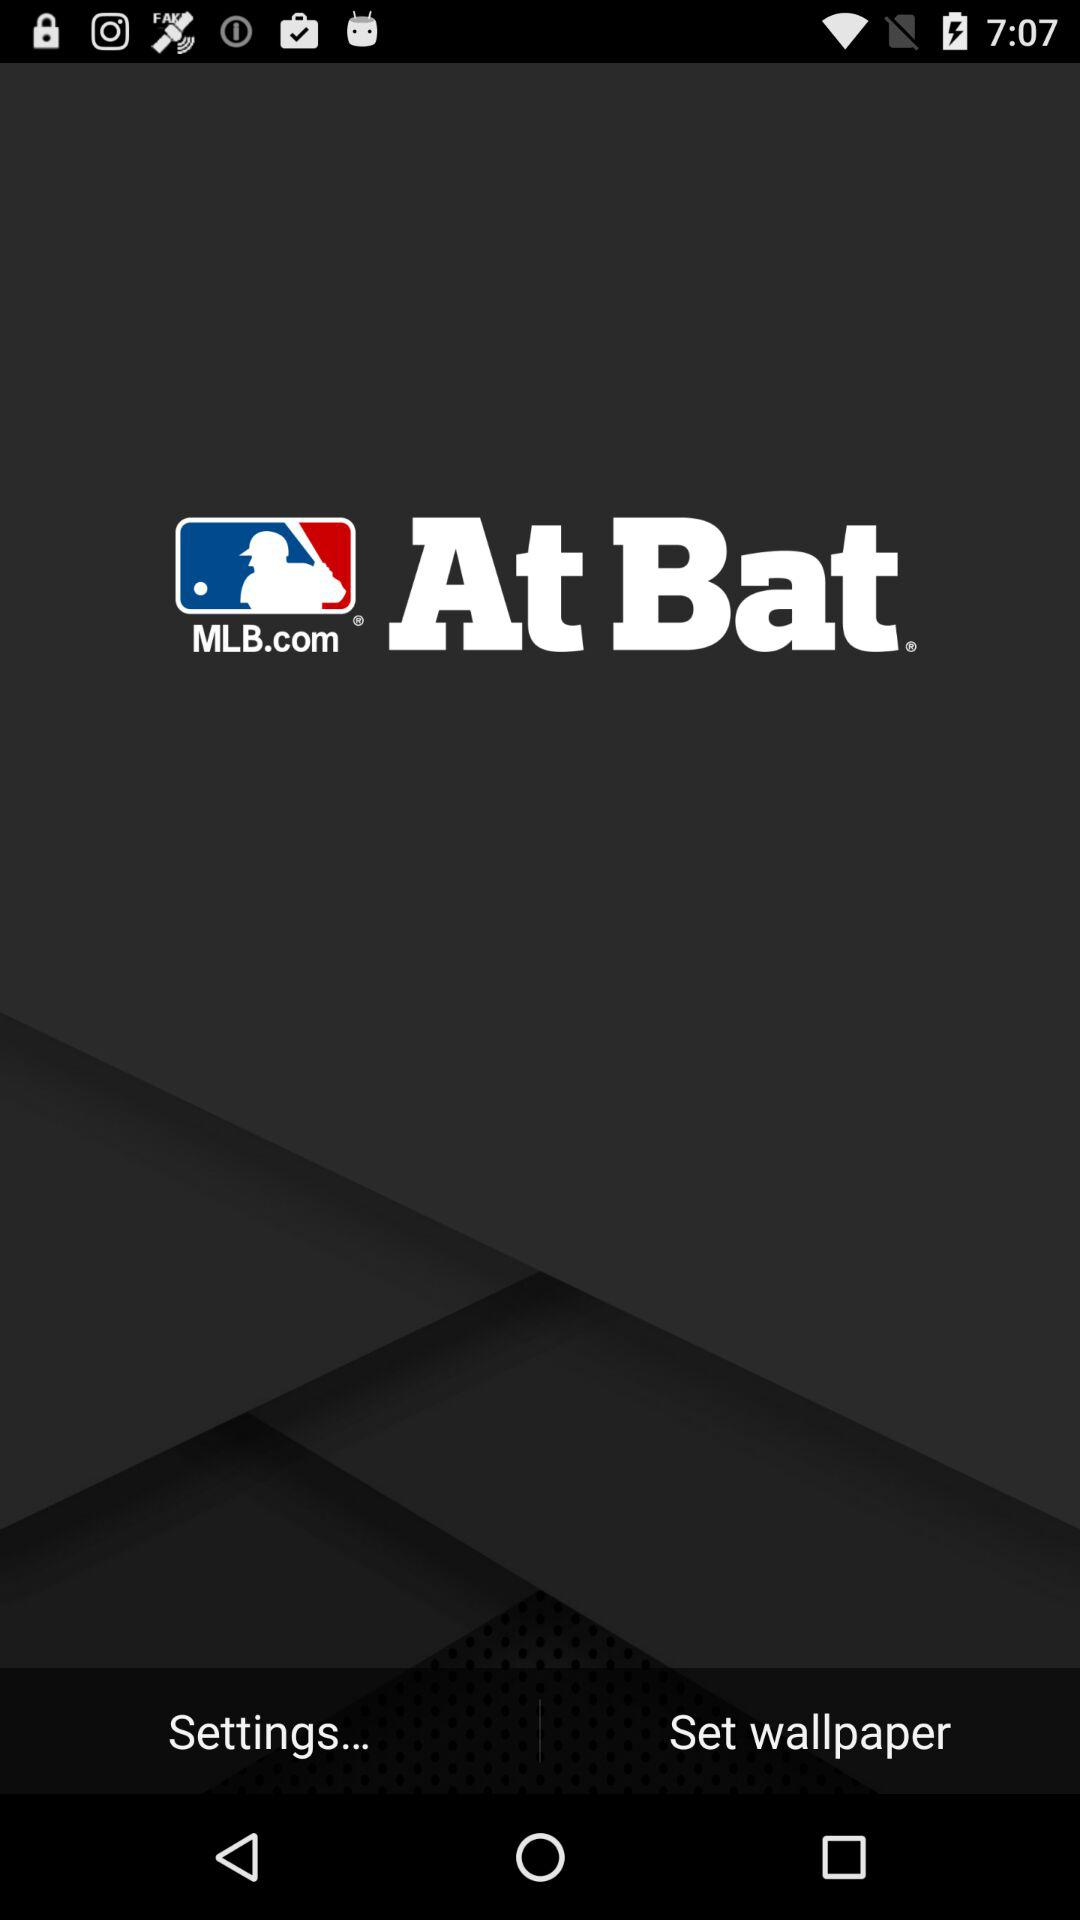What is the name of the application?
When the provided information is insufficient, respond with <no answer>. <no answer> 